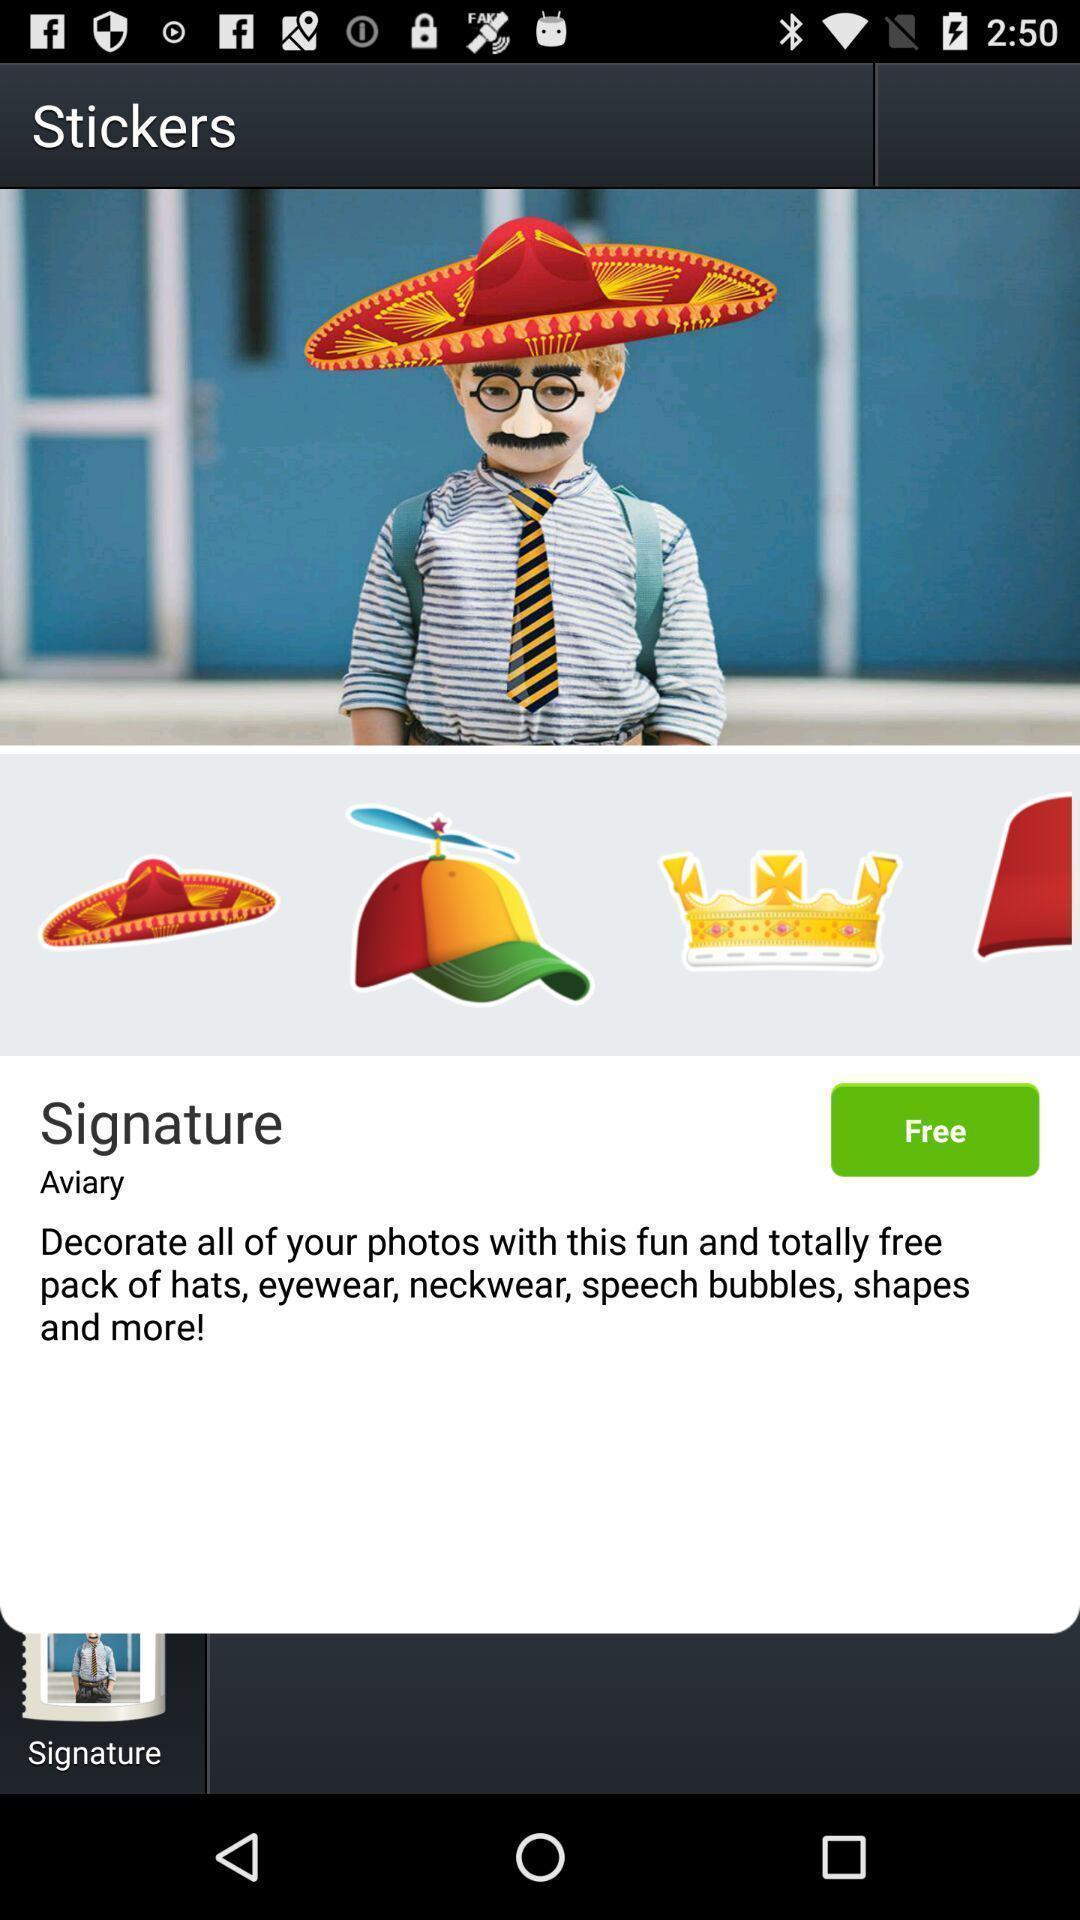Tell me what you see in this picture. Various stickers to use in the mobile for app. 